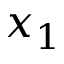<formula> <loc_0><loc_0><loc_500><loc_500>x _ { 1 }</formula> 